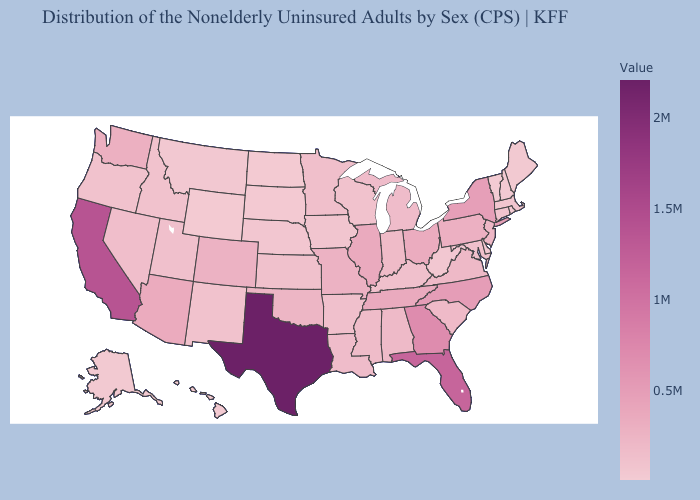Does Vermont have the lowest value in the USA?
Concise answer only. Yes. Does Texas have the highest value in the South?
Concise answer only. Yes. Which states hav the highest value in the Northeast?
Be succinct. New York. Which states hav the highest value in the Northeast?
Keep it brief. New York. Does the map have missing data?
Give a very brief answer. No. Among the states that border Ohio , does Pennsylvania have the lowest value?
Concise answer only. No. Is the legend a continuous bar?
Give a very brief answer. Yes. Does New York have the highest value in the Northeast?
Write a very short answer. Yes. 